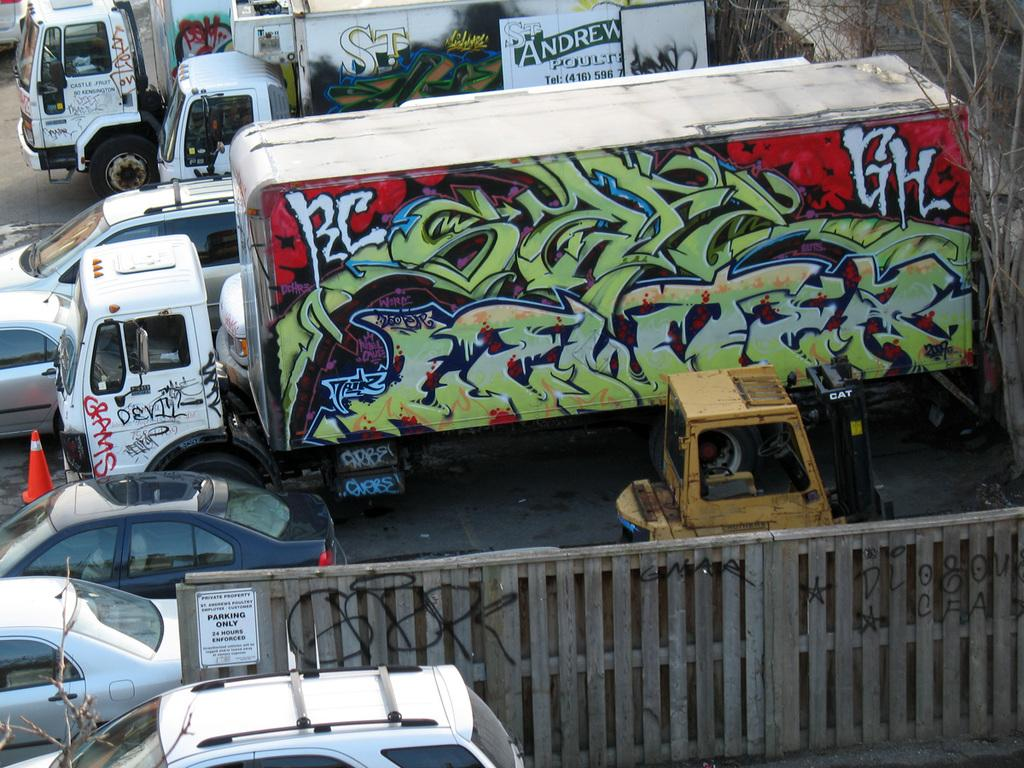What types of vehicles are present in the image? There are many cars and trucks in the image. Can you describe the location of the truck in the image? There is a truck on the left side of the image. What is unique about the truck in the image? The truck has graffiti on it. What can be seen on the right side of the image? There are trees on the right side of the image. What type of bean is being cooked in the image? There is no bean present in the image; it features cars, trucks, a truck with graffiti, trees, and a railing. 